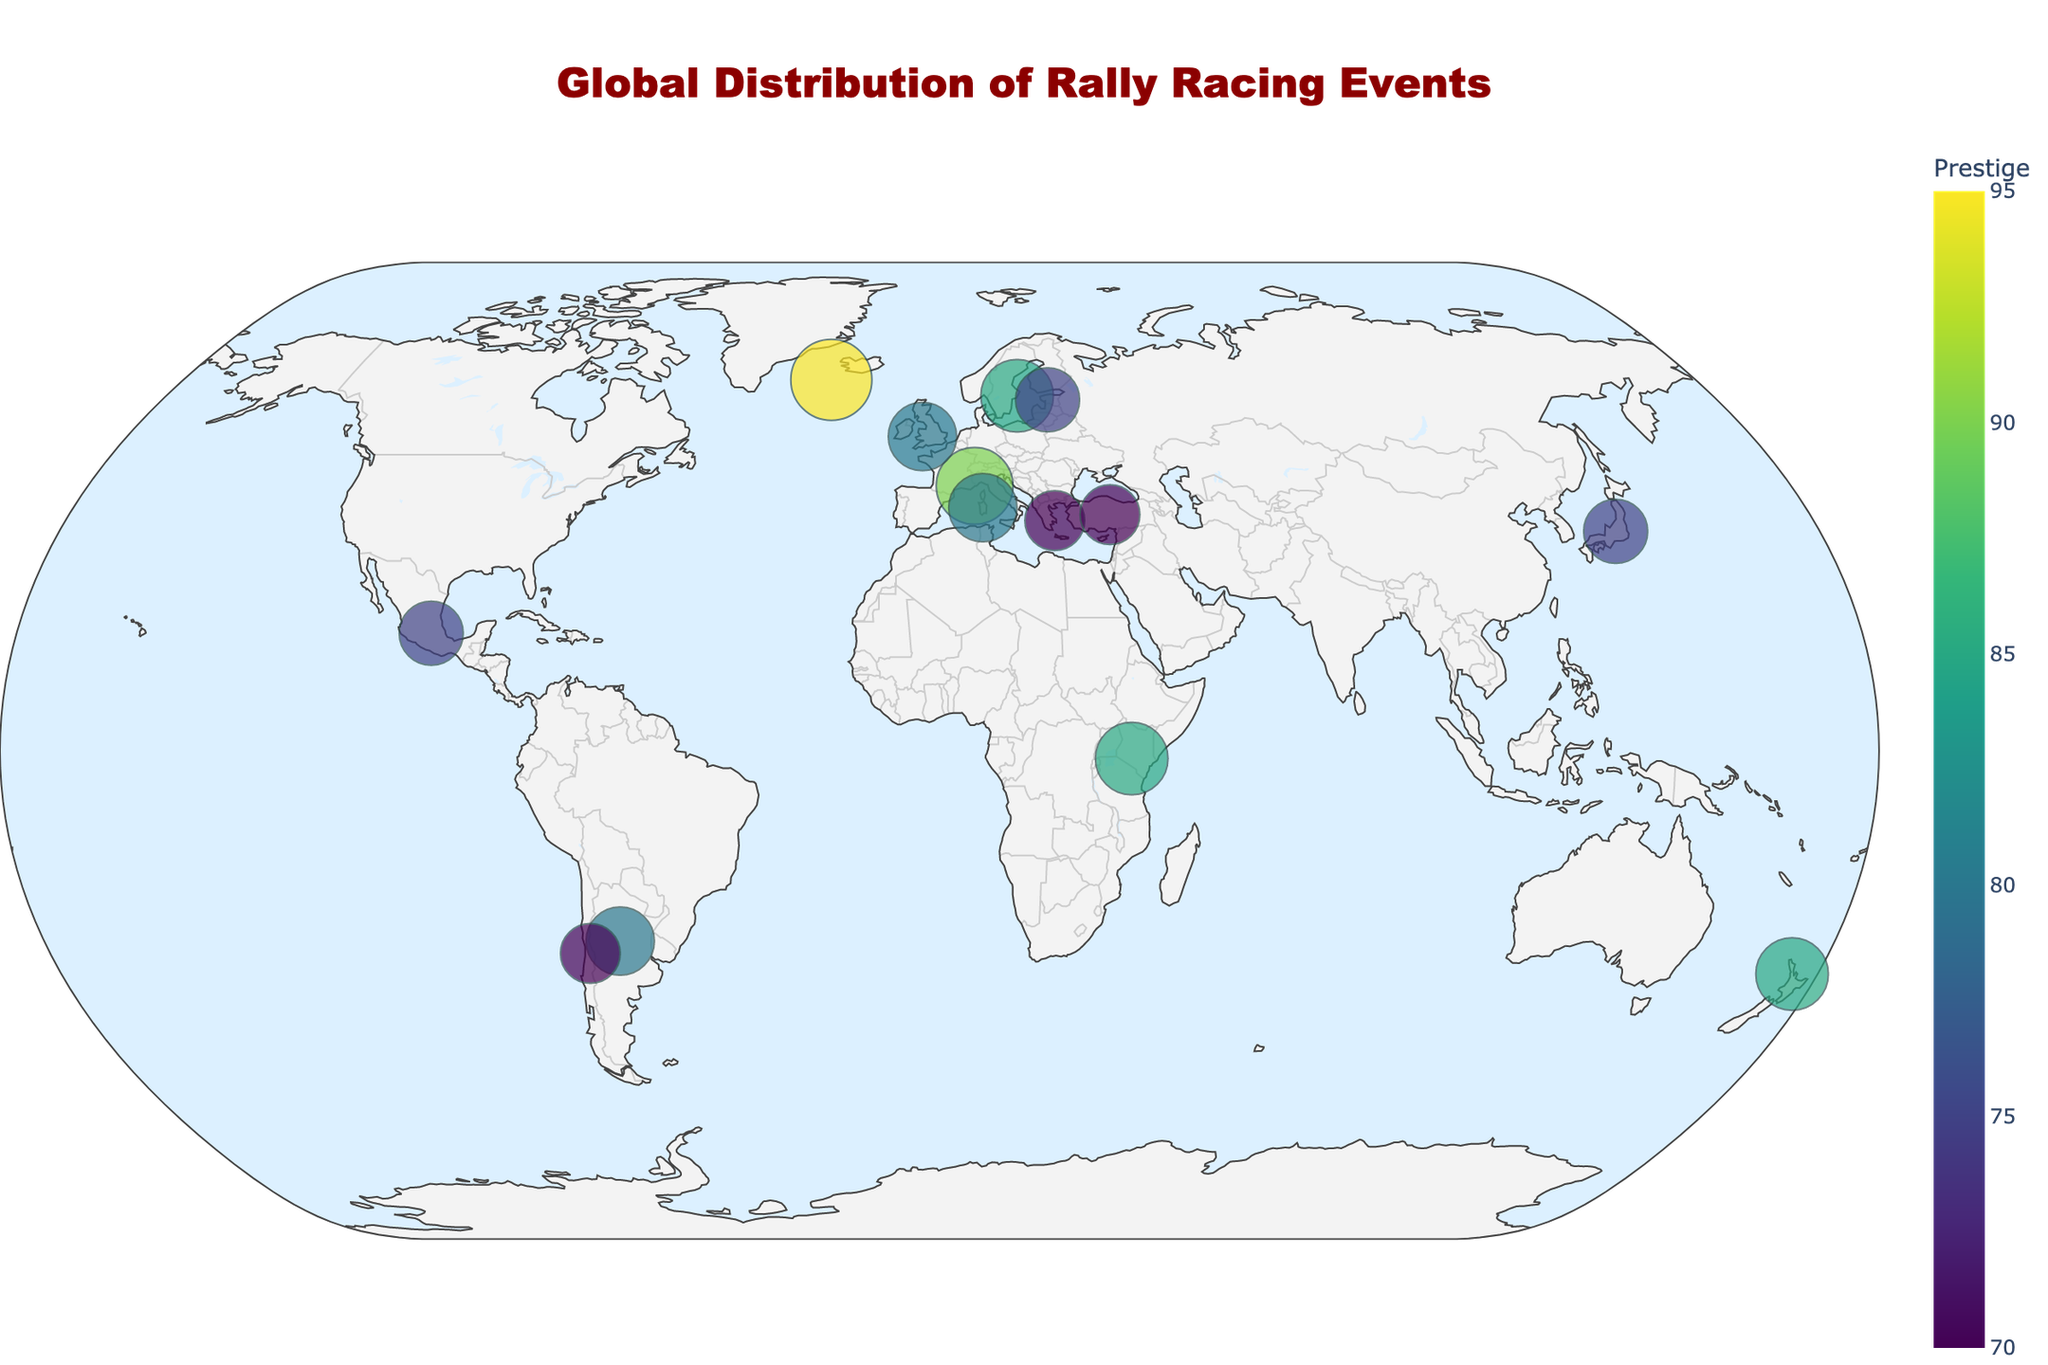What's the title of the figure? The title is typically found at the top of the plot in larger and distinctive font size compared to other text elements. In this case, it is "Global Distribution of Rally Racing Events".
Answer: Global Distribution of Rally Racing Events Which rally racing event has the highest prestige? By looking at the color scale indicated in the plot, the event with the highest value for "Prestige" will be indicated. Rally Finland has the highest prestige value of 95, represented with the largest marker.
Answer: Rally Finland Which countries have biennial events? Countries with biennial events will have text annotations on the plot indicating "Biennial". Referring to the figure, we see that Japan and Chile host biennial events.
Answer: Japan and Chile What is the average prestige of events in Europe? To find this, identify the events in Europe, then sum their prestige values and divide by the number of events: Finland (95), Monaco (90), Greece (70), Sweden (85), UK (80), Estonia (75), and Turkey (70). Average = (95+90+70+85+80+75+70)/7.
Answer: 80.71 Which event has a higher prestige, Rally Argentina or Wales Rally GB? By comparing the prestige values of both events from their markers, we see that Rally Argentina has a prestige of 80 and Wales Rally GB also has 80.
Answer: They are equal How many events have a prestige of 85? Count the events marked with the color corresponding to the value 85 from the color bar. There are 3 events: Safari Rally, Rally Sweden, and Rally New Zealand.
Answer: 3 Which region has more annual events, Europe or South America? Count the annual events in each region: Europe (Finland, Monaco, Greece, Sweden, UK, Estonia, Turkey: 7) and South America (Argentina: 1).
Answer: Europe Are there more triennial events or biennial events? Look for text annotations indicating frequency: Triennial (New Zealand: 1), Biennial (Japan, Chile: 2).
Answer: Biennial Which annual event is closest to the equator? Find annual events near the equator by checking latitudes, and the closest one to 0° latitude is Safari Rally in Kenya (-1.2921).
Answer: Safari Rally What is the total number of unique rally events depicted in the plot? Count all unique event names provided in the plotted data, which are highlighted by unique marker points on the map. There are 14 unique events.
Answer: 14 